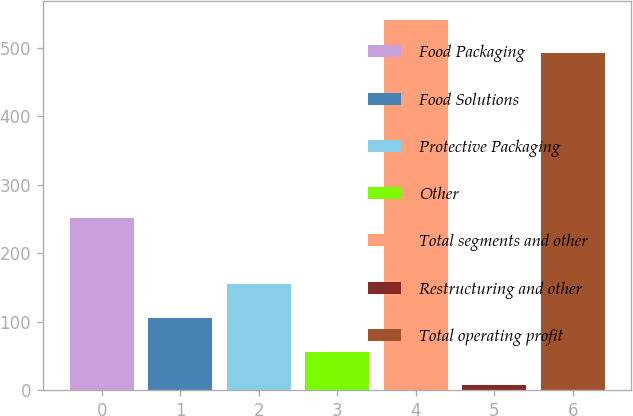Convert chart. <chart><loc_0><loc_0><loc_500><loc_500><bar_chart><fcel>Food Packaging<fcel>Food Solutions<fcel>Protective Packaging<fcel>Other<fcel>Total segments and other<fcel>Restructuring and other<fcel>Total operating profit<nl><fcel>251.7<fcel>105.46<fcel>154.69<fcel>56.23<fcel>541.53<fcel>7<fcel>492.3<nl></chart> 